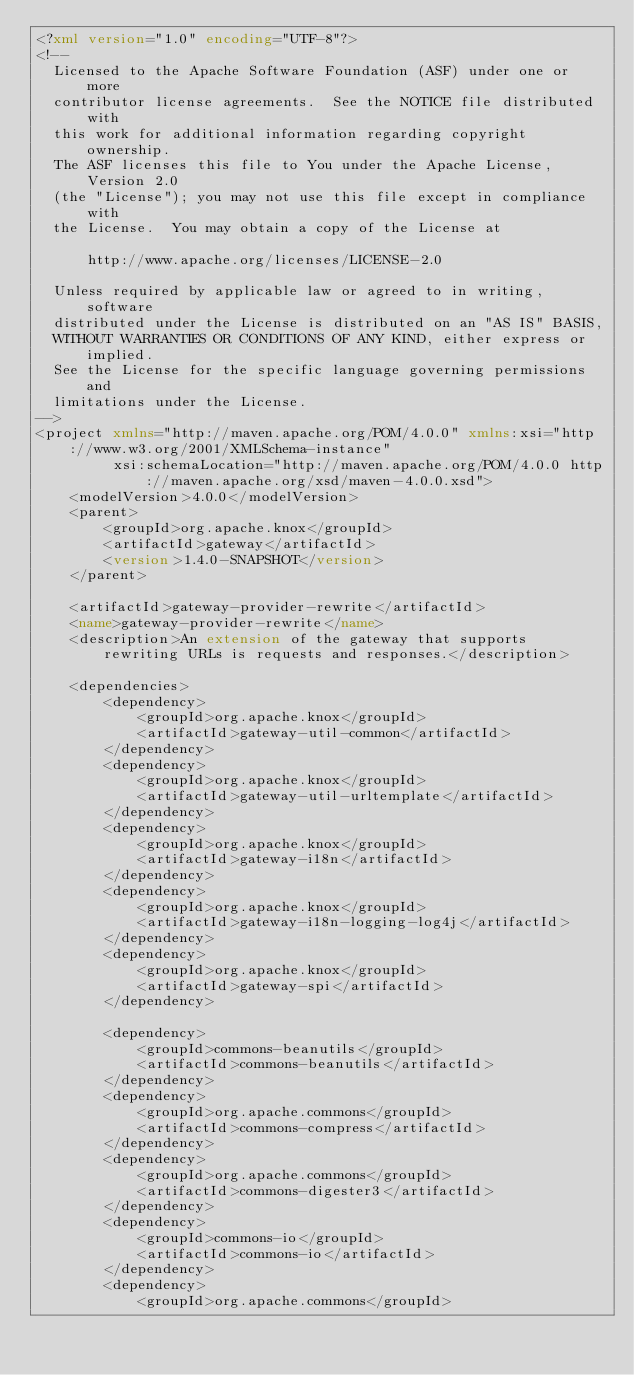Convert code to text. <code><loc_0><loc_0><loc_500><loc_500><_XML_><?xml version="1.0" encoding="UTF-8"?>
<!--
  Licensed to the Apache Software Foundation (ASF) under one or more
  contributor license agreements.  See the NOTICE file distributed with
  this work for additional information regarding copyright ownership.
  The ASF licenses this file to You under the Apache License, Version 2.0
  (the "License"); you may not use this file except in compliance with
  the License.  You may obtain a copy of the License at

      http://www.apache.org/licenses/LICENSE-2.0

  Unless required by applicable law or agreed to in writing, software
  distributed under the License is distributed on an "AS IS" BASIS,
  WITHOUT WARRANTIES OR CONDITIONS OF ANY KIND, either express or implied.
  See the License for the specific language governing permissions and
  limitations under the License.
-->
<project xmlns="http://maven.apache.org/POM/4.0.0" xmlns:xsi="http://www.w3.org/2001/XMLSchema-instance"
         xsi:schemaLocation="http://maven.apache.org/POM/4.0.0 http://maven.apache.org/xsd/maven-4.0.0.xsd">
    <modelVersion>4.0.0</modelVersion>
    <parent>
        <groupId>org.apache.knox</groupId>
        <artifactId>gateway</artifactId>
        <version>1.4.0-SNAPSHOT</version>
    </parent>

    <artifactId>gateway-provider-rewrite</artifactId>
    <name>gateway-provider-rewrite</name>
    <description>An extension of the gateway that supports rewriting URLs is requests and responses.</description>

    <dependencies>
        <dependency>
            <groupId>org.apache.knox</groupId>
            <artifactId>gateway-util-common</artifactId>
        </dependency>
        <dependency>
            <groupId>org.apache.knox</groupId>
            <artifactId>gateway-util-urltemplate</artifactId>
        </dependency>
        <dependency>
            <groupId>org.apache.knox</groupId>
            <artifactId>gateway-i18n</artifactId>
        </dependency>
        <dependency>
            <groupId>org.apache.knox</groupId>
            <artifactId>gateway-i18n-logging-log4j</artifactId>
        </dependency>
        <dependency>
            <groupId>org.apache.knox</groupId>
            <artifactId>gateway-spi</artifactId>
        </dependency>

        <dependency>
            <groupId>commons-beanutils</groupId>
            <artifactId>commons-beanutils</artifactId>
        </dependency>
        <dependency>
            <groupId>org.apache.commons</groupId>
            <artifactId>commons-compress</artifactId>
        </dependency>
        <dependency>
            <groupId>org.apache.commons</groupId>
            <artifactId>commons-digester3</artifactId>
        </dependency>
        <dependency>
            <groupId>commons-io</groupId>
            <artifactId>commons-io</artifactId>
        </dependency>
        <dependency>
            <groupId>org.apache.commons</groupId></code> 